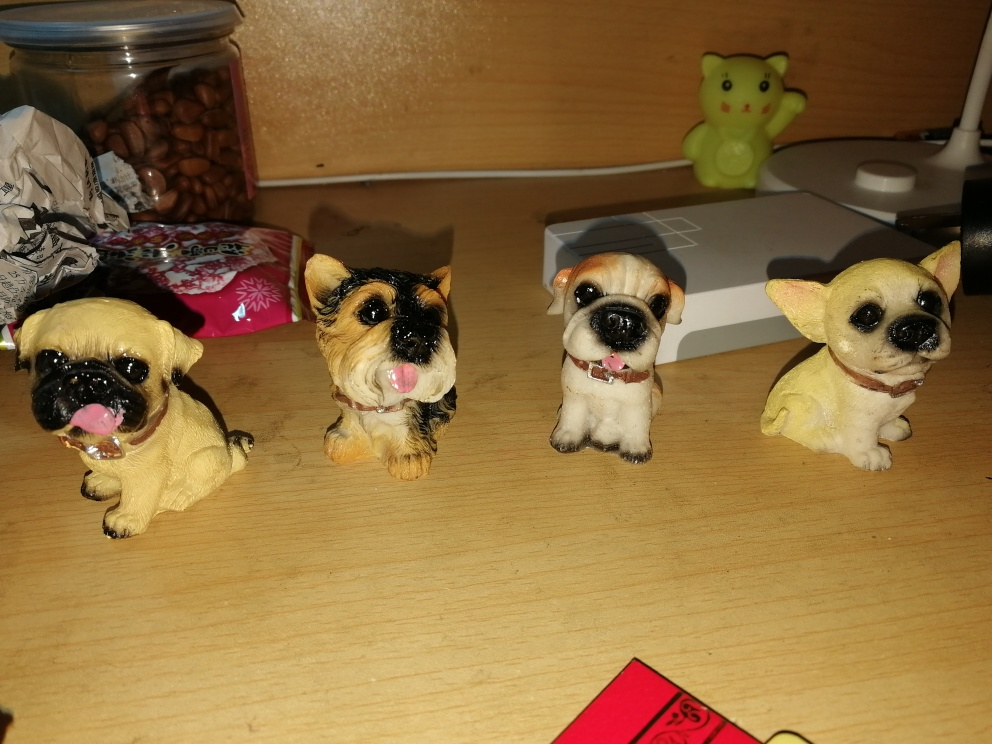Can you tell me more about the different breeds these figurines might represent? While these are stylized representations and not exact replicas, starting from the left, the first figurine resembles a Pug with its distinguishable short-muzzled face and curled tail. The second could be a Yorkshire Terrier known for its small size and long, luxurious coat. The third figurine seems to mimic a Bulldog's features, with a squashed face and muscular body. Finally, the last one appears to resemble a Chihuahua with its large eyes and compact size. 